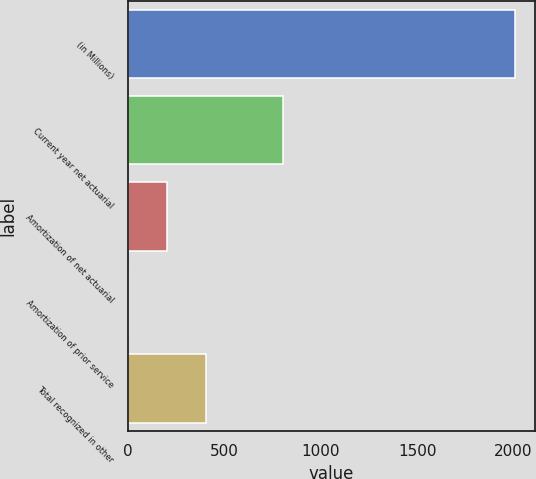Convert chart to OTSL. <chart><loc_0><loc_0><loc_500><loc_500><bar_chart><fcel>(in Millions)<fcel>Current year net actuarial<fcel>Amortization of net actuarial<fcel>Amortization of prior service<fcel>Total recognized in other<nl><fcel>2009<fcel>804.14<fcel>201.71<fcel>0.9<fcel>402.52<nl></chart> 